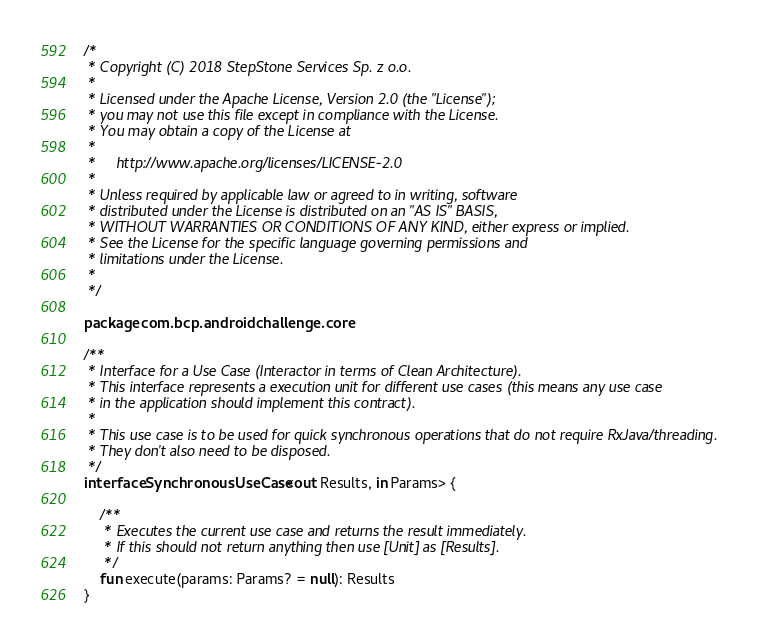<code> <loc_0><loc_0><loc_500><loc_500><_Kotlin_>/*
 * Copyright (C) 2018 StepStone Services Sp. z o.o.
 *
 * Licensed under the Apache License, Version 2.0 (the "License");
 * you may not use this file except in compliance with the License.
 * You may obtain a copy of the License at
 *
 *     http://www.apache.org/licenses/LICENSE-2.0
 *
 * Unless required by applicable law or agreed to in writing, software
 * distributed under the License is distributed on an "AS IS" BASIS,
 * WITHOUT WARRANTIES OR CONDITIONS OF ANY KIND, either express or implied.
 * See the License for the specific language governing permissions and
 * limitations under the License.
 *
 */

package com.bcp.androidchallenge.core

/**
 * Interface for a Use Case (Interactor in terms of Clean Architecture).
 * This interface represents a execution unit for different use cases (this means any use case
 * in the application should implement this contract).
 *
 * This use case is to be used for quick synchronous operations that do not require RxJava/threading.
 * They don't also need to be disposed.
 */
interface SynchronousUseCase<out Results, in Params> {

    /**
     * Executes the current use case and returns the result immediately.
     * If this should not return anything then use [Unit] as [Results].
     */
    fun execute(params: Params? = null): Results
}
</code> 